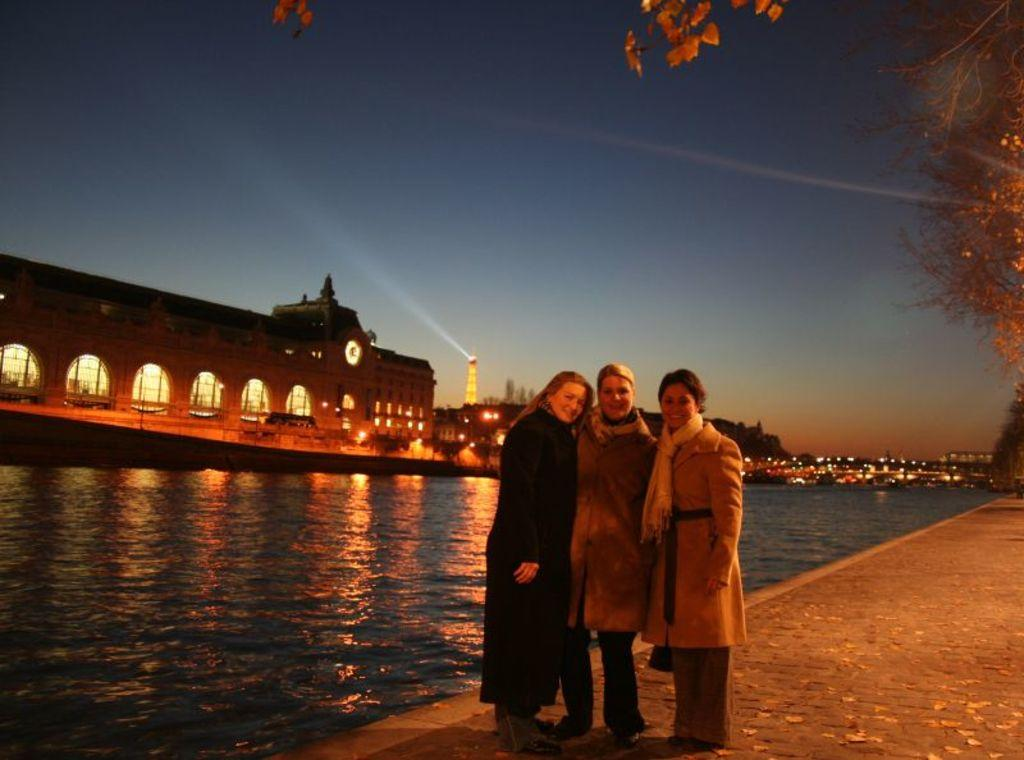How many women are in the image? There are three women standing in the image. What are the women wearing? The women are wearing clothes. What type of path can be seen in the image? There is a footpath in the image. What type of vegetation is present in the image? There are trees in the image. What type of structure can be seen in the image? There is a building in the image. What time-telling device is present in the image? There is a clock in the image. What type of water feature is visible in the image? There is water visible in the image. What type of navigational structure is present in the image? There is a lighthouse in the image. What part of the natural environment is visible in the image? The sky is visible in the image. Where is the pencil located in the image? There is no pencil present in the image. What type of food is being served in the lunchroom in the image? There is no lunchroom present in the image. 